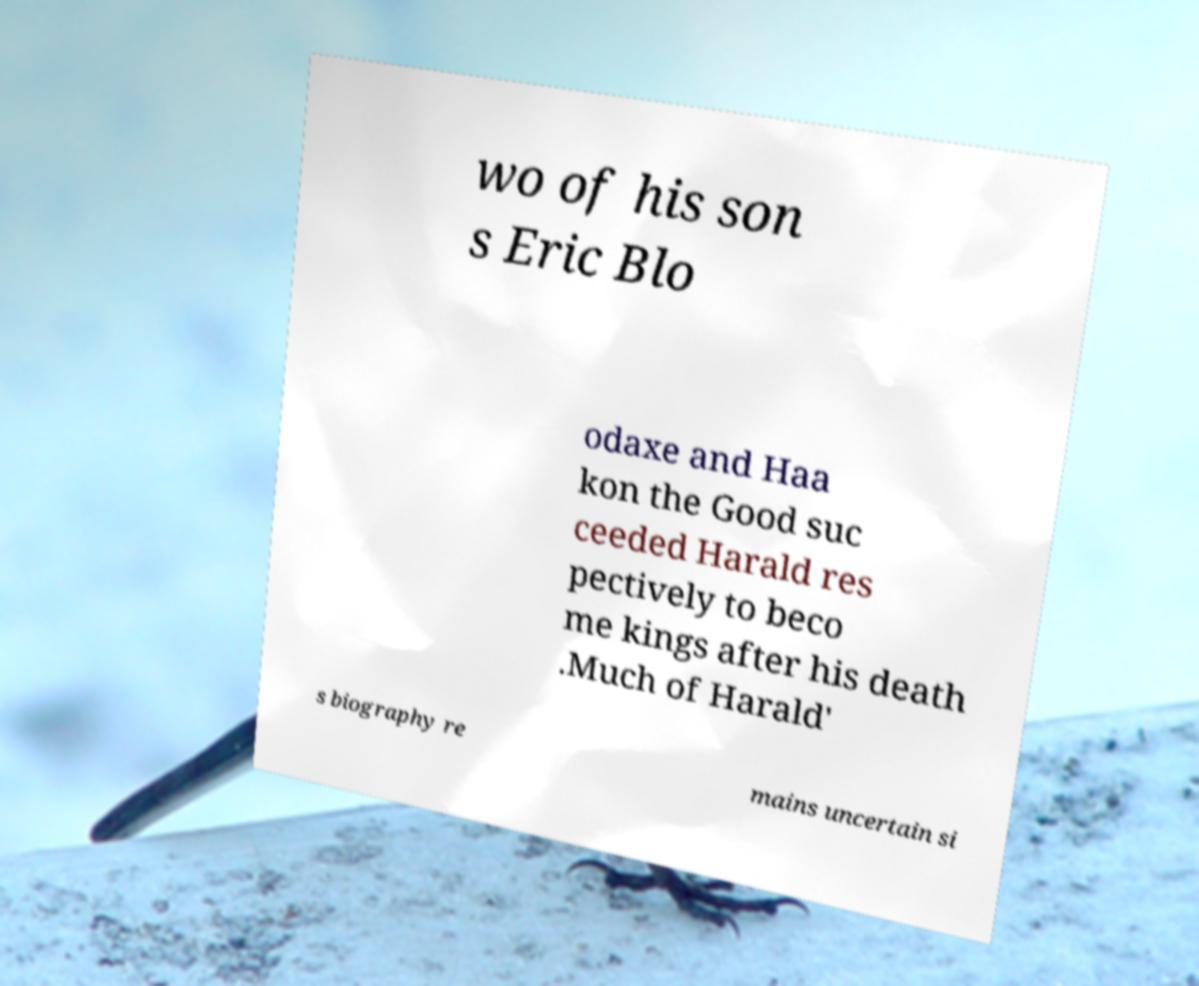I need the written content from this picture converted into text. Can you do that? wo of his son s Eric Blo odaxe and Haa kon the Good suc ceeded Harald res pectively to beco me kings after his death .Much of Harald' s biography re mains uncertain si 